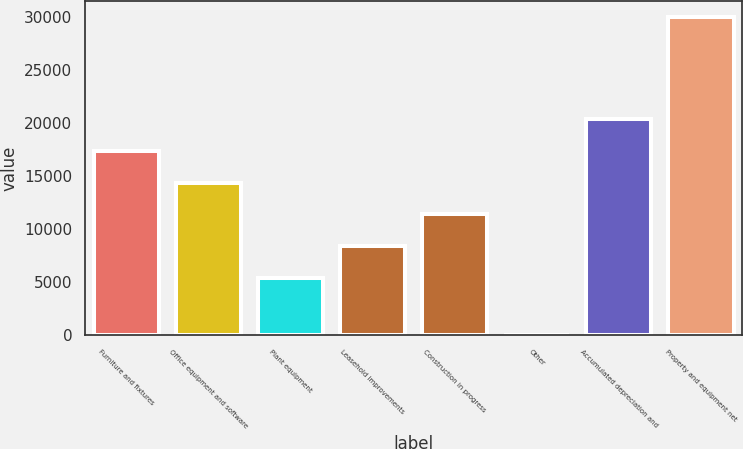Convert chart. <chart><loc_0><loc_0><loc_500><loc_500><bar_chart><fcel>Furniture and fixtures<fcel>Office equipment and software<fcel>Plant equipment<fcel>Leasehold improvements<fcel>Construction in progress<fcel>Other<fcel>Accumulated depreciation and<fcel>Property and equipment net<nl><fcel>17360.6<fcel>14370.7<fcel>5401<fcel>8390.9<fcel>11380.8<fcel>24<fcel>20350.5<fcel>29923<nl></chart> 